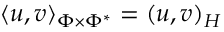<formula> <loc_0><loc_0><loc_500><loc_500>\langle u , v \rangle _ { \Phi \times \Phi ^ { * } } = ( u , v ) _ { H }</formula> 